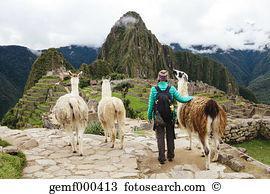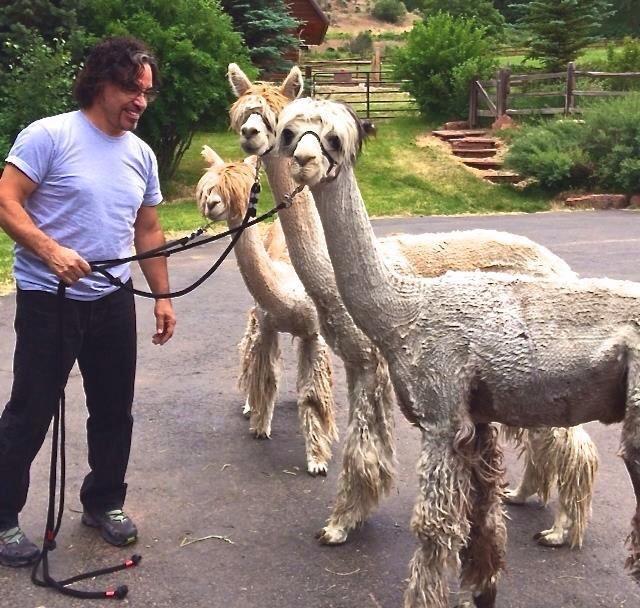The first image is the image on the left, the second image is the image on the right. Evaluate the accuracy of this statement regarding the images: "The left image contains no more than one person interacting with a llama.". Is it true? Answer yes or no. Yes. The first image is the image on the left, the second image is the image on the right. Evaluate the accuracy of this statement regarding the images: "There are exactly six llamas in total.". Is it true? Answer yes or no. Yes. 